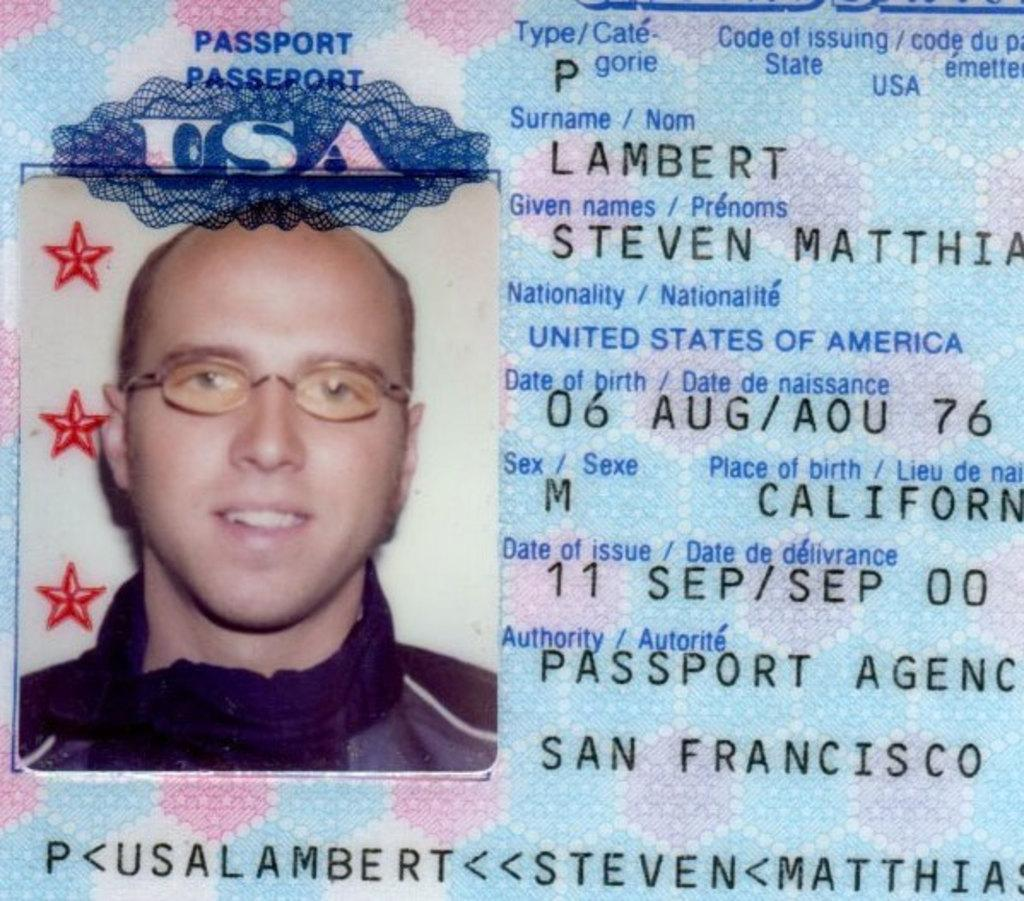What can be seen written on the image? There is text and numbers written on the image. Can you describe the person in the image? There is a person in the image, and they are smiling. What type of wind can be seen blowing the representative's flag in the image? There is no representative or flag present in the image, so it is not possible to answer that question. 